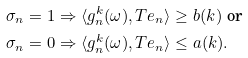<formula> <loc_0><loc_0><loc_500><loc_500>& \sigma _ { n } = 1 \Rightarrow \langle g _ { n } ^ { k } ( \omega ) , T e _ { n } \rangle \geq b ( k ) \ \text {or} \\ & \sigma _ { n } = 0 \Rightarrow \langle g _ { n } ^ { k } ( \omega ) , T e _ { n } \rangle \leq a ( k ) . \</formula> 